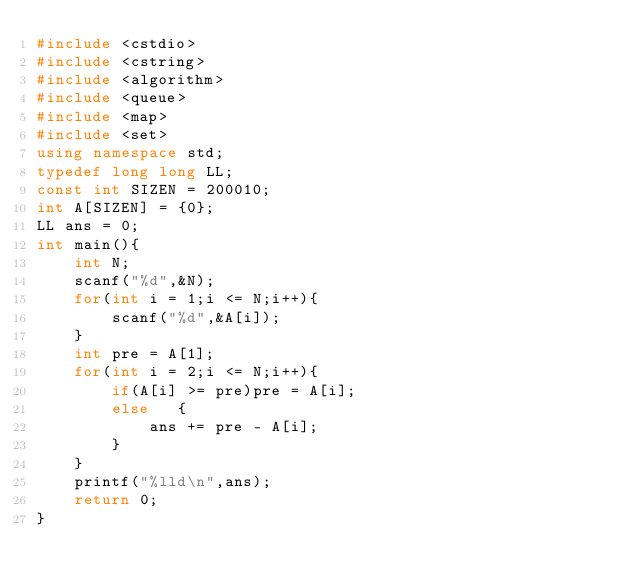<code> <loc_0><loc_0><loc_500><loc_500><_C++_>#include <cstdio>
#include <cstring>
#include <algorithm>
#include <queue>
#include <map>
#include <set>
using namespace std;
typedef long long LL;
const int SIZEN = 200010;
int A[SIZEN] = {0};
LL ans = 0;
int main(){
    int N;
    scanf("%d",&N);
    for(int i = 1;i <= N;i++){
        scanf("%d",&A[i]);
    }
    int pre = A[1];
    for(int i = 2;i <= N;i++){
        if(A[i] >= pre)pre = A[i];
        else   {
            ans += pre - A[i];
        }
    }
    printf("%lld\n",ans);
    return 0;
}</code> 